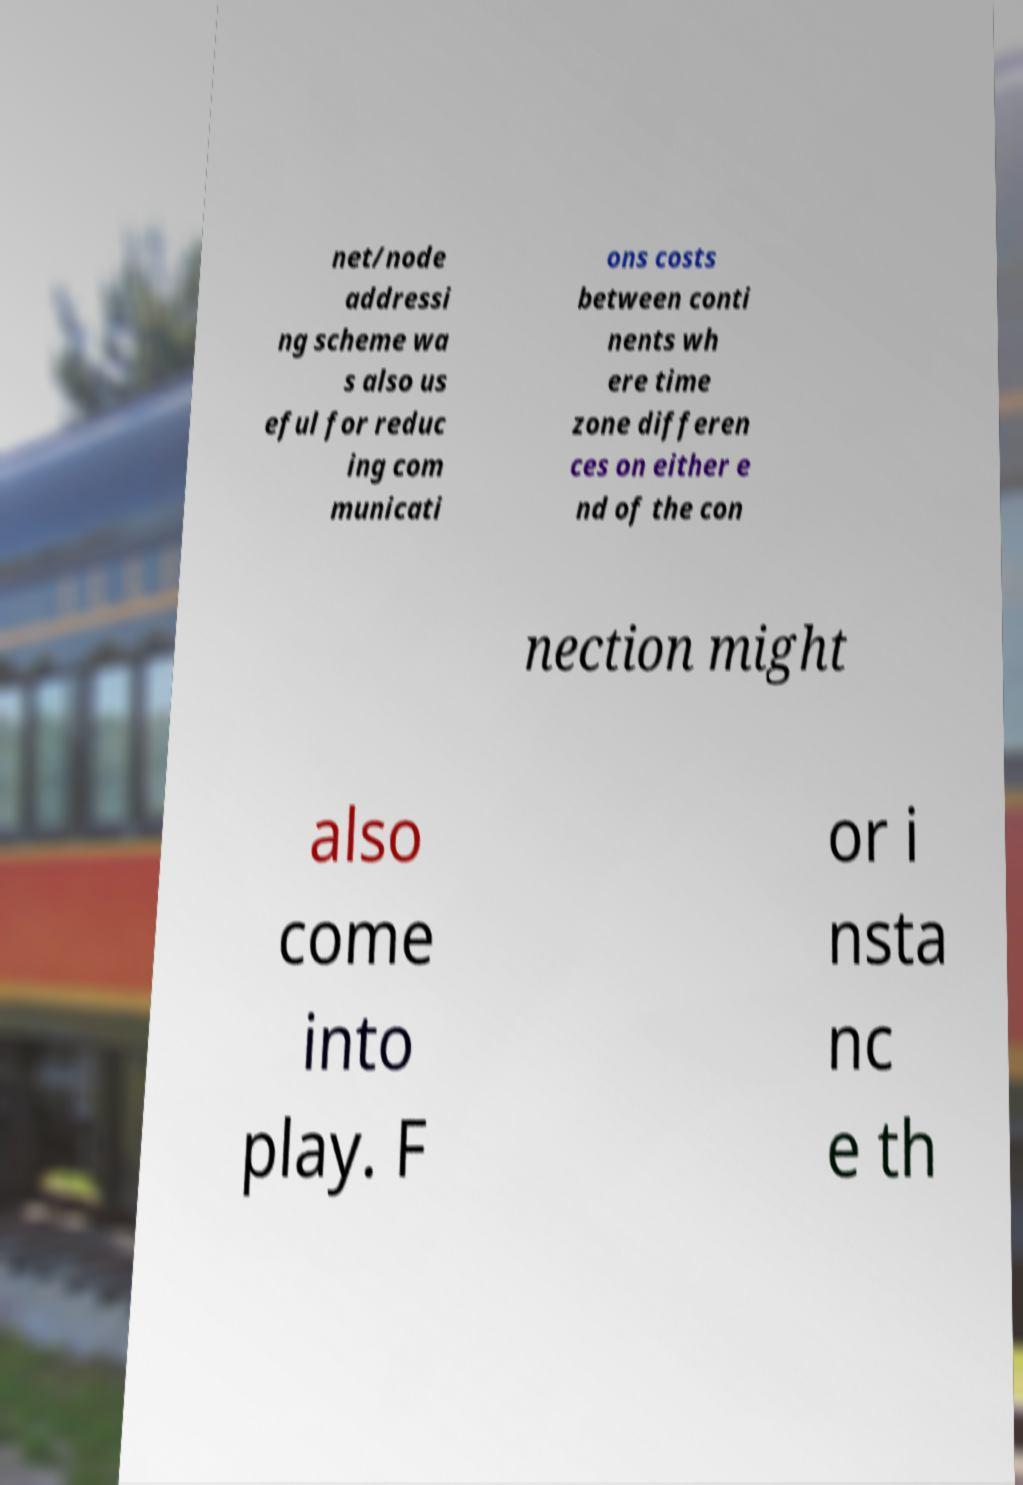Can you accurately transcribe the text from the provided image for me? net/node addressi ng scheme wa s also us eful for reduc ing com municati ons costs between conti nents wh ere time zone differen ces on either e nd of the con nection might also come into play. F or i nsta nc e th 